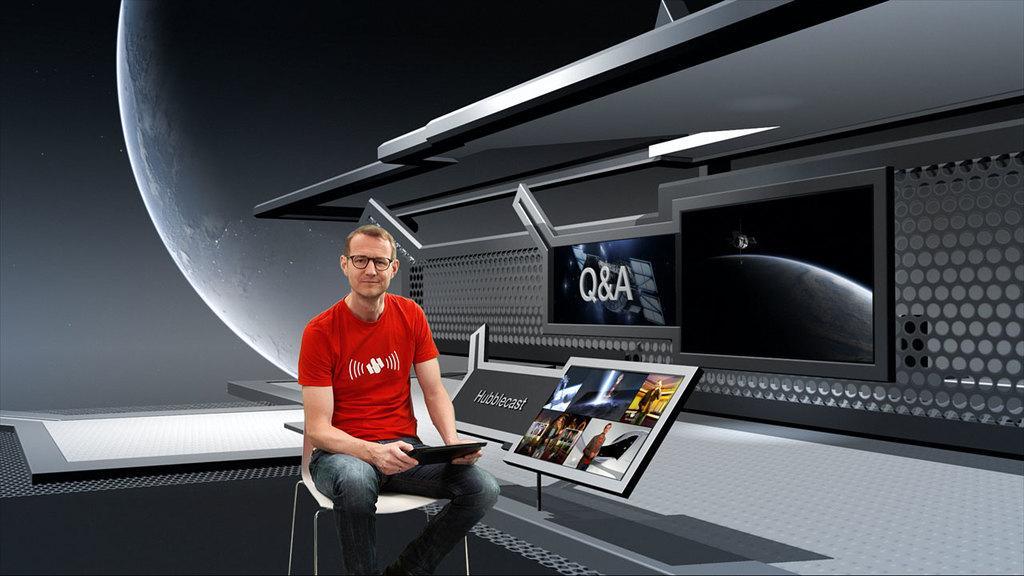Describe this image in one or two sentences. This picture is an animated picture. In the center, there is a person sitting on the chair. He is wearing a red t shirt and grey jeans and he is holding something. Beside him, there is a screen with people. In the background there is a planet. 